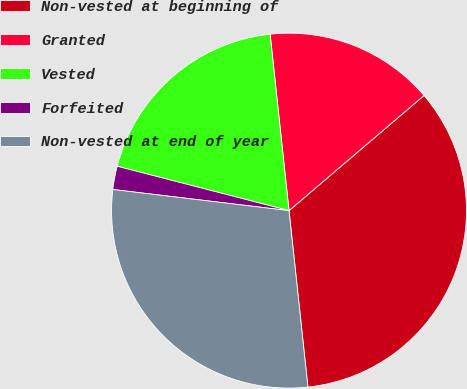Convert chart. <chart><loc_0><loc_0><loc_500><loc_500><pie_chart><fcel>Non-vested at beginning of<fcel>Granted<fcel>Vested<fcel>Forfeited<fcel>Non-vested at end of year<nl><fcel>34.54%<fcel>15.46%<fcel>19.28%<fcel>2.12%<fcel>28.6%<nl></chart> 